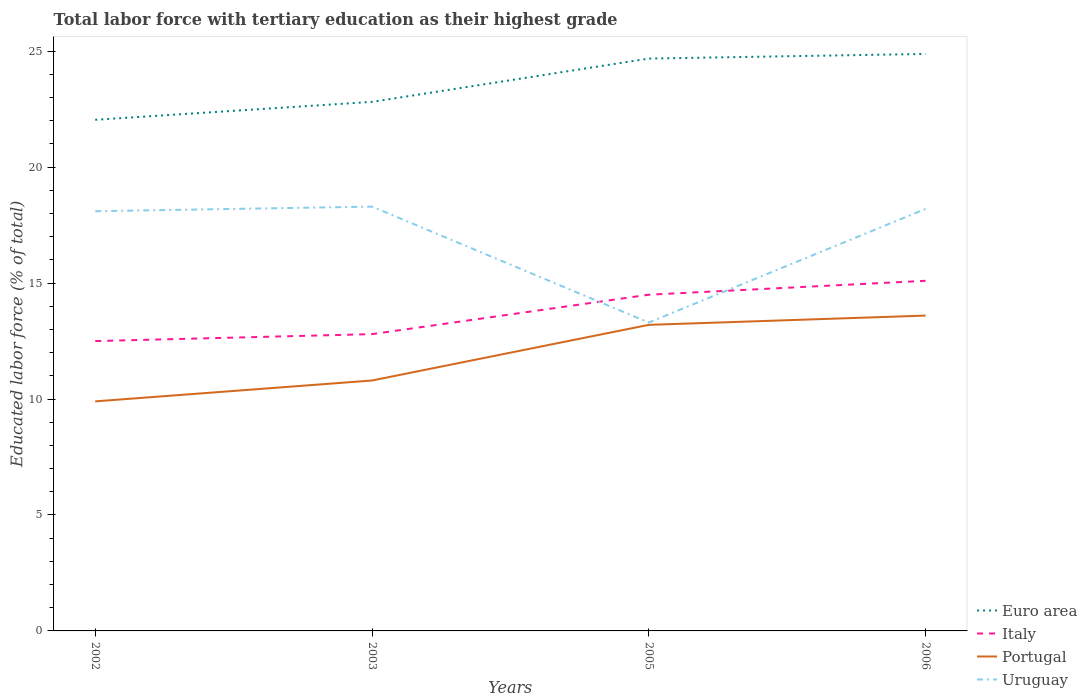How many different coloured lines are there?
Offer a terse response. 4. Is the number of lines equal to the number of legend labels?
Your answer should be compact. Yes. What is the total percentage of male labor force with tertiary education in Euro area in the graph?
Keep it short and to the point. -1.87. What is the difference between the highest and the second highest percentage of male labor force with tertiary education in Italy?
Offer a terse response. 2.6. How many lines are there?
Your response must be concise. 4. Does the graph contain any zero values?
Provide a succinct answer. No. Where does the legend appear in the graph?
Provide a short and direct response. Bottom right. What is the title of the graph?
Your answer should be compact. Total labor force with tertiary education as their highest grade. What is the label or title of the X-axis?
Offer a terse response. Years. What is the label or title of the Y-axis?
Your answer should be very brief. Educated labor force (% of total). What is the Educated labor force (% of total) in Euro area in 2002?
Give a very brief answer. 22.04. What is the Educated labor force (% of total) of Portugal in 2002?
Provide a short and direct response. 9.9. What is the Educated labor force (% of total) of Uruguay in 2002?
Your response must be concise. 18.1. What is the Educated labor force (% of total) of Euro area in 2003?
Your answer should be compact. 22.82. What is the Educated labor force (% of total) in Italy in 2003?
Your answer should be compact. 12.8. What is the Educated labor force (% of total) in Portugal in 2003?
Provide a succinct answer. 10.8. What is the Educated labor force (% of total) of Uruguay in 2003?
Offer a terse response. 18.3. What is the Educated labor force (% of total) of Euro area in 2005?
Offer a very short reply. 24.68. What is the Educated labor force (% of total) of Portugal in 2005?
Your answer should be compact. 13.2. What is the Educated labor force (% of total) of Uruguay in 2005?
Your response must be concise. 13.3. What is the Educated labor force (% of total) of Euro area in 2006?
Offer a very short reply. 24.88. What is the Educated labor force (% of total) of Italy in 2006?
Your answer should be very brief. 15.1. What is the Educated labor force (% of total) of Portugal in 2006?
Provide a short and direct response. 13.6. What is the Educated labor force (% of total) in Uruguay in 2006?
Offer a terse response. 18.2. Across all years, what is the maximum Educated labor force (% of total) in Euro area?
Your answer should be very brief. 24.88. Across all years, what is the maximum Educated labor force (% of total) in Italy?
Offer a very short reply. 15.1. Across all years, what is the maximum Educated labor force (% of total) of Portugal?
Your answer should be compact. 13.6. Across all years, what is the maximum Educated labor force (% of total) in Uruguay?
Your answer should be compact. 18.3. Across all years, what is the minimum Educated labor force (% of total) in Euro area?
Make the answer very short. 22.04. Across all years, what is the minimum Educated labor force (% of total) of Italy?
Offer a terse response. 12.5. Across all years, what is the minimum Educated labor force (% of total) of Portugal?
Provide a short and direct response. 9.9. Across all years, what is the minimum Educated labor force (% of total) of Uruguay?
Keep it short and to the point. 13.3. What is the total Educated labor force (% of total) of Euro area in the graph?
Ensure brevity in your answer.  94.43. What is the total Educated labor force (% of total) of Italy in the graph?
Offer a very short reply. 54.9. What is the total Educated labor force (% of total) of Portugal in the graph?
Your answer should be very brief. 47.5. What is the total Educated labor force (% of total) in Uruguay in the graph?
Provide a short and direct response. 67.9. What is the difference between the Educated labor force (% of total) of Euro area in 2002 and that in 2003?
Offer a very short reply. -0.77. What is the difference between the Educated labor force (% of total) in Portugal in 2002 and that in 2003?
Offer a very short reply. -0.9. What is the difference between the Educated labor force (% of total) in Euro area in 2002 and that in 2005?
Your response must be concise. -2.64. What is the difference between the Educated labor force (% of total) of Italy in 2002 and that in 2005?
Keep it short and to the point. -2. What is the difference between the Educated labor force (% of total) in Uruguay in 2002 and that in 2005?
Ensure brevity in your answer.  4.8. What is the difference between the Educated labor force (% of total) of Euro area in 2002 and that in 2006?
Give a very brief answer. -2.84. What is the difference between the Educated labor force (% of total) of Italy in 2002 and that in 2006?
Provide a succinct answer. -2.6. What is the difference between the Educated labor force (% of total) in Portugal in 2002 and that in 2006?
Ensure brevity in your answer.  -3.7. What is the difference between the Educated labor force (% of total) of Euro area in 2003 and that in 2005?
Provide a short and direct response. -1.87. What is the difference between the Educated labor force (% of total) of Portugal in 2003 and that in 2005?
Ensure brevity in your answer.  -2.4. What is the difference between the Educated labor force (% of total) of Uruguay in 2003 and that in 2005?
Provide a succinct answer. 5. What is the difference between the Educated labor force (% of total) in Euro area in 2003 and that in 2006?
Provide a succinct answer. -2.07. What is the difference between the Educated labor force (% of total) in Italy in 2003 and that in 2006?
Your response must be concise. -2.3. What is the difference between the Educated labor force (% of total) of Portugal in 2003 and that in 2006?
Your response must be concise. -2.8. What is the difference between the Educated labor force (% of total) of Uruguay in 2003 and that in 2006?
Ensure brevity in your answer.  0.1. What is the difference between the Educated labor force (% of total) of Euro area in 2005 and that in 2006?
Offer a very short reply. -0.2. What is the difference between the Educated labor force (% of total) in Italy in 2005 and that in 2006?
Provide a succinct answer. -0.6. What is the difference between the Educated labor force (% of total) of Portugal in 2005 and that in 2006?
Offer a very short reply. -0.4. What is the difference between the Educated labor force (% of total) in Uruguay in 2005 and that in 2006?
Offer a terse response. -4.9. What is the difference between the Educated labor force (% of total) in Euro area in 2002 and the Educated labor force (% of total) in Italy in 2003?
Keep it short and to the point. 9.24. What is the difference between the Educated labor force (% of total) of Euro area in 2002 and the Educated labor force (% of total) of Portugal in 2003?
Your answer should be very brief. 11.24. What is the difference between the Educated labor force (% of total) in Euro area in 2002 and the Educated labor force (% of total) in Uruguay in 2003?
Your response must be concise. 3.74. What is the difference between the Educated labor force (% of total) of Euro area in 2002 and the Educated labor force (% of total) of Italy in 2005?
Ensure brevity in your answer.  7.54. What is the difference between the Educated labor force (% of total) of Euro area in 2002 and the Educated labor force (% of total) of Portugal in 2005?
Give a very brief answer. 8.84. What is the difference between the Educated labor force (% of total) of Euro area in 2002 and the Educated labor force (% of total) of Uruguay in 2005?
Your answer should be very brief. 8.74. What is the difference between the Educated labor force (% of total) of Euro area in 2002 and the Educated labor force (% of total) of Italy in 2006?
Provide a succinct answer. 6.94. What is the difference between the Educated labor force (% of total) in Euro area in 2002 and the Educated labor force (% of total) in Portugal in 2006?
Make the answer very short. 8.44. What is the difference between the Educated labor force (% of total) of Euro area in 2002 and the Educated labor force (% of total) of Uruguay in 2006?
Give a very brief answer. 3.84. What is the difference between the Educated labor force (% of total) in Italy in 2002 and the Educated labor force (% of total) in Uruguay in 2006?
Your response must be concise. -5.7. What is the difference between the Educated labor force (% of total) in Euro area in 2003 and the Educated labor force (% of total) in Italy in 2005?
Offer a very short reply. 8.32. What is the difference between the Educated labor force (% of total) in Euro area in 2003 and the Educated labor force (% of total) in Portugal in 2005?
Offer a terse response. 9.62. What is the difference between the Educated labor force (% of total) of Euro area in 2003 and the Educated labor force (% of total) of Uruguay in 2005?
Your response must be concise. 9.52. What is the difference between the Educated labor force (% of total) in Italy in 2003 and the Educated labor force (% of total) in Uruguay in 2005?
Offer a very short reply. -0.5. What is the difference between the Educated labor force (% of total) of Portugal in 2003 and the Educated labor force (% of total) of Uruguay in 2005?
Your answer should be compact. -2.5. What is the difference between the Educated labor force (% of total) in Euro area in 2003 and the Educated labor force (% of total) in Italy in 2006?
Offer a terse response. 7.72. What is the difference between the Educated labor force (% of total) of Euro area in 2003 and the Educated labor force (% of total) of Portugal in 2006?
Provide a short and direct response. 9.22. What is the difference between the Educated labor force (% of total) in Euro area in 2003 and the Educated labor force (% of total) in Uruguay in 2006?
Your answer should be very brief. 4.62. What is the difference between the Educated labor force (% of total) of Italy in 2003 and the Educated labor force (% of total) of Portugal in 2006?
Keep it short and to the point. -0.8. What is the difference between the Educated labor force (% of total) in Euro area in 2005 and the Educated labor force (% of total) in Italy in 2006?
Offer a terse response. 9.58. What is the difference between the Educated labor force (% of total) in Euro area in 2005 and the Educated labor force (% of total) in Portugal in 2006?
Make the answer very short. 11.08. What is the difference between the Educated labor force (% of total) in Euro area in 2005 and the Educated labor force (% of total) in Uruguay in 2006?
Your response must be concise. 6.48. What is the difference between the Educated labor force (% of total) of Italy in 2005 and the Educated labor force (% of total) of Portugal in 2006?
Offer a very short reply. 0.9. What is the average Educated labor force (% of total) of Euro area per year?
Offer a very short reply. 23.61. What is the average Educated labor force (% of total) of Italy per year?
Your answer should be compact. 13.72. What is the average Educated labor force (% of total) in Portugal per year?
Your answer should be very brief. 11.88. What is the average Educated labor force (% of total) of Uruguay per year?
Give a very brief answer. 16.98. In the year 2002, what is the difference between the Educated labor force (% of total) in Euro area and Educated labor force (% of total) in Italy?
Provide a short and direct response. 9.54. In the year 2002, what is the difference between the Educated labor force (% of total) of Euro area and Educated labor force (% of total) of Portugal?
Your answer should be compact. 12.14. In the year 2002, what is the difference between the Educated labor force (% of total) of Euro area and Educated labor force (% of total) of Uruguay?
Your response must be concise. 3.94. In the year 2002, what is the difference between the Educated labor force (% of total) in Italy and Educated labor force (% of total) in Uruguay?
Ensure brevity in your answer.  -5.6. In the year 2003, what is the difference between the Educated labor force (% of total) of Euro area and Educated labor force (% of total) of Italy?
Your answer should be compact. 10.02. In the year 2003, what is the difference between the Educated labor force (% of total) of Euro area and Educated labor force (% of total) of Portugal?
Give a very brief answer. 12.02. In the year 2003, what is the difference between the Educated labor force (% of total) in Euro area and Educated labor force (% of total) in Uruguay?
Your answer should be very brief. 4.52. In the year 2003, what is the difference between the Educated labor force (% of total) in Italy and Educated labor force (% of total) in Portugal?
Your response must be concise. 2. In the year 2003, what is the difference between the Educated labor force (% of total) of Portugal and Educated labor force (% of total) of Uruguay?
Make the answer very short. -7.5. In the year 2005, what is the difference between the Educated labor force (% of total) of Euro area and Educated labor force (% of total) of Italy?
Your response must be concise. 10.18. In the year 2005, what is the difference between the Educated labor force (% of total) of Euro area and Educated labor force (% of total) of Portugal?
Ensure brevity in your answer.  11.48. In the year 2005, what is the difference between the Educated labor force (% of total) in Euro area and Educated labor force (% of total) in Uruguay?
Ensure brevity in your answer.  11.38. In the year 2005, what is the difference between the Educated labor force (% of total) of Portugal and Educated labor force (% of total) of Uruguay?
Your response must be concise. -0.1. In the year 2006, what is the difference between the Educated labor force (% of total) of Euro area and Educated labor force (% of total) of Italy?
Provide a succinct answer. 9.78. In the year 2006, what is the difference between the Educated labor force (% of total) in Euro area and Educated labor force (% of total) in Portugal?
Your answer should be very brief. 11.28. In the year 2006, what is the difference between the Educated labor force (% of total) in Euro area and Educated labor force (% of total) in Uruguay?
Give a very brief answer. 6.68. In the year 2006, what is the difference between the Educated labor force (% of total) of Italy and Educated labor force (% of total) of Uruguay?
Ensure brevity in your answer.  -3.1. In the year 2006, what is the difference between the Educated labor force (% of total) of Portugal and Educated labor force (% of total) of Uruguay?
Provide a succinct answer. -4.6. What is the ratio of the Educated labor force (% of total) in Euro area in 2002 to that in 2003?
Make the answer very short. 0.97. What is the ratio of the Educated labor force (% of total) in Italy in 2002 to that in 2003?
Keep it short and to the point. 0.98. What is the ratio of the Educated labor force (% of total) in Portugal in 2002 to that in 2003?
Keep it short and to the point. 0.92. What is the ratio of the Educated labor force (% of total) of Uruguay in 2002 to that in 2003?
Your response must be concise. 0.99. What is the ratio of the Educated labor force (% of total) in Euro area in 2002 to that in 2005?
Make the answer very short. 0.89. What is the ratio of the Educated labor force (% of total) of Italy in 2002 to that in 2005?
Your answer should be compact. 0.86. What is the ratio of the Educated labor force (% of total) in Portugal in 2002 to that in 2005?
Ensure brevity in your answer.  0.75. What is the ratio of the Educated labor force (% of total) of Uruguay in 2002 to that in 2005?
Give a very brief answer. 1.36. What is the ratio of the Educated labor force (% of total) of Euro area in 2002 to that in 2006?
Provide a succinct answer. 0.89. What is the ratio of the Educated labor force (% of total) in Italy in 2002 to that in 2006?
Keep it short and to the point. 0.83. What is the ratio of the Educated labor force (% of total) in Portugal in 2002 to that in 2006?
Ensure brevity in your answer.  0.73. What is the ratio of the Educated labor force (% of total) in Uruguay in 2002 to that in 2006?
Your answer should be very brief. 0.99. What is the ratio of the Educated labor force (% of total) in Euro area in 2003 to that in 2005?
Your response must be concise. 0.92. What is the ratio of the Educated labor force (% of total) in Italy in 2003 to that in 2005?
Provide a short and direct response. 0.88. What is the ratio of the Educated labor force (% of total) in Portugal in 2003 to that in 2005?
Give a very brief answer. 0.82. What is the ratio of the Educated labor force (% of total) of Uruguay in 2003 to that in 2005?
Your answer should be compact. 1.38. What is the ratio of the Educated labor force (% of total) in Euro area in 2003 to that in 2006?
Your answer should be compact. 0.92. What is the ratio of the Educated labor force (% of total) of Italy in 2003 to that in 2006?
Make the answer very short. 0.85. What is the ratio of the Educated labor force (% of total) in Portugal in 2003 to that in 2006?
Offer a very short reply. 0.79. What is the ratio of the Educated labor force (% of total) in Italy in 2005 to that in 2006?
Your answer should be compact. 0.96. What is the ratio of the Educated labor force (% of total) of Portugal in 2005 to that in 2006?
Offer a terse response. 0.97. What is the ratio of the Educated labor force (% of total) of Uruguay in 2005 to that in 2006?
Make the answer very short. 0.73. What is the difference between the highest and the second highest Educated labor force (% of total) of Euro area?
Provide a short and direct response. 0.2. What is the difference between the highest and the second highest Educated labor force (% of total) of Italy?
Your response must be concise. 0.6. What is the difference between the highest and the lowest Educated labor force (% of total) of Euro area?
Your response must be concise. 2.84. What is the difference between the highest and the lowest Educated labor force (% of total) in Italy?
Your response must be concise. 2.6. 